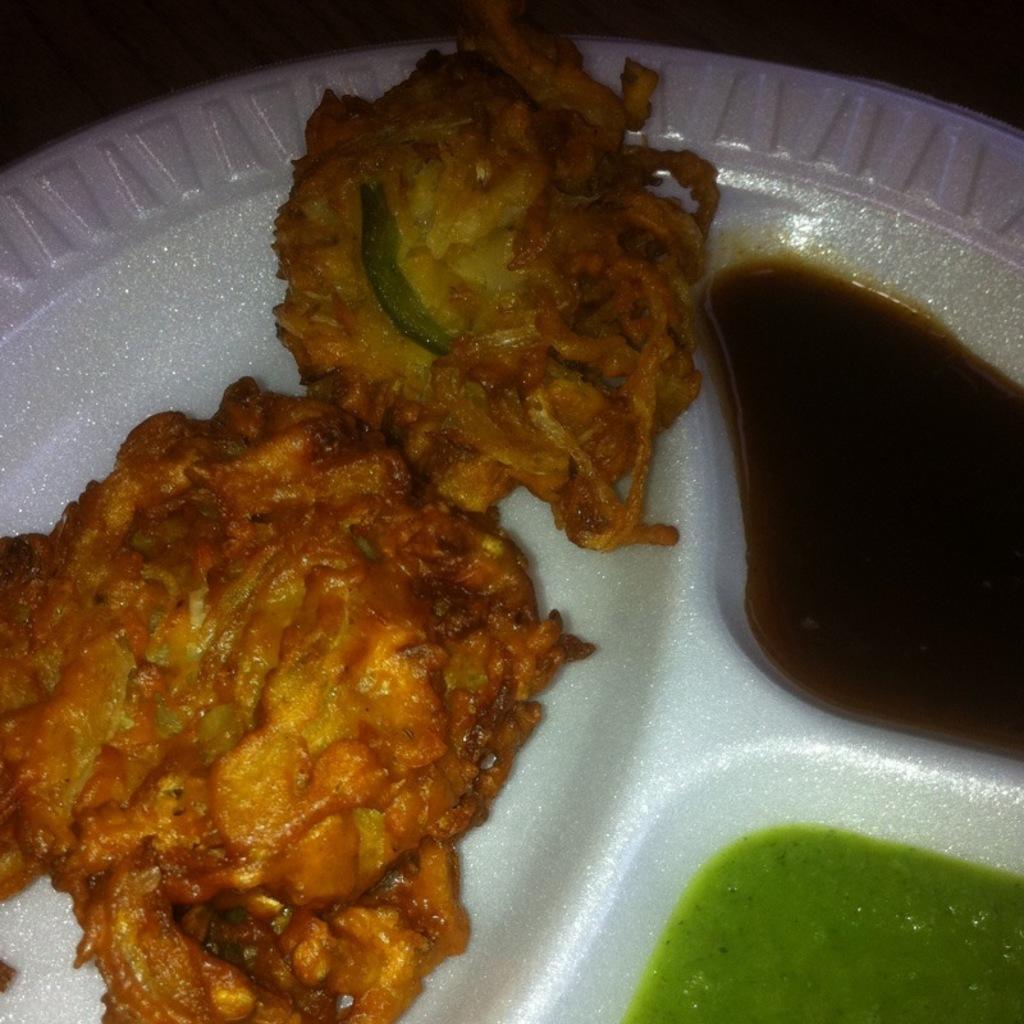Can you describe this image briefly? In this image we can see a plate with snacks and some sauce. 